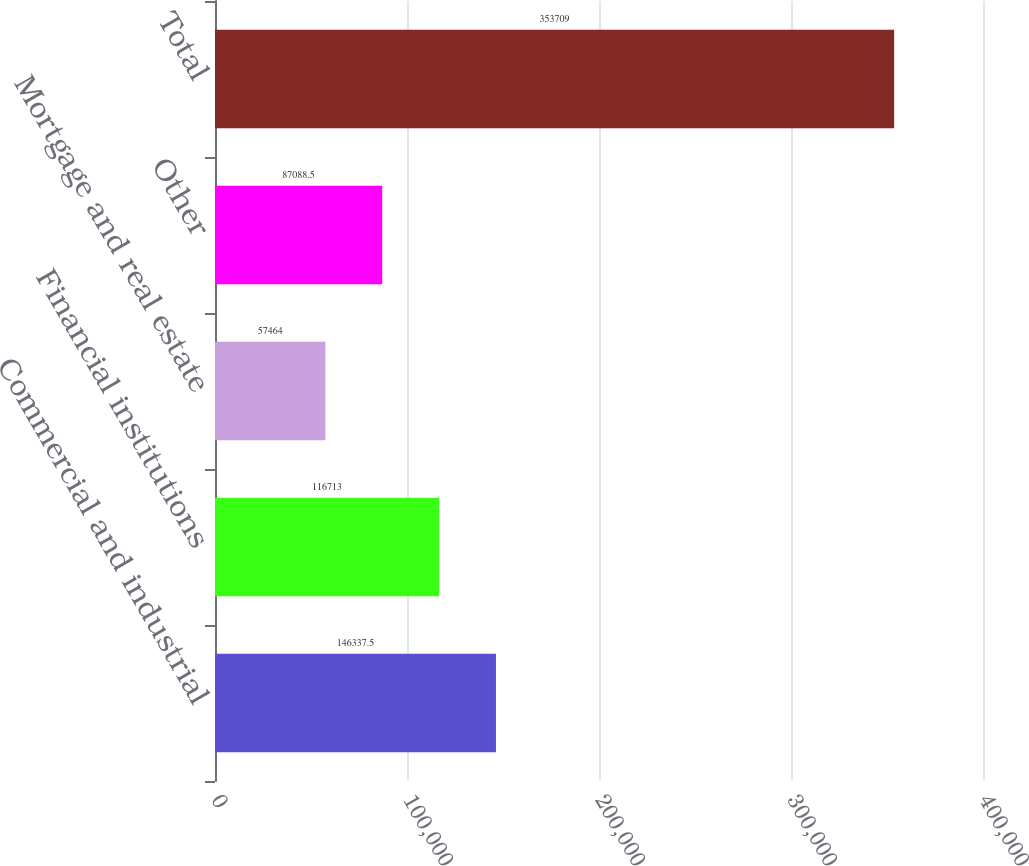Convert chart. <chart><loc_0><loc_0><loc_500><loc_500><bar_chart><fcel>Commercial and industrial<fcel>Financial institutions<fcel>Mortgage and real estate<fcel>Other<fcel>Total<nl><fcel>146338<fcel>116713<fcel>57464<fcel>87088.5<fcel>353709<nl></chart> 